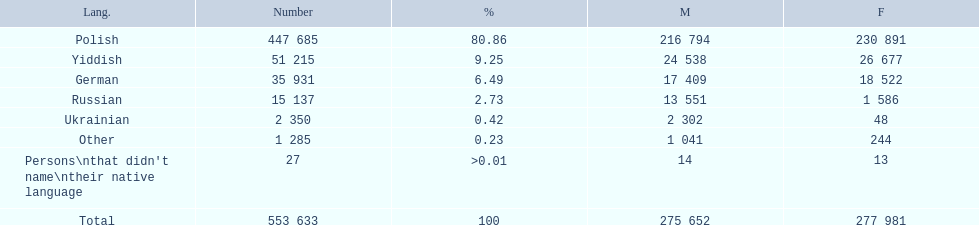Which is the least spoken language? Ukrainian. 